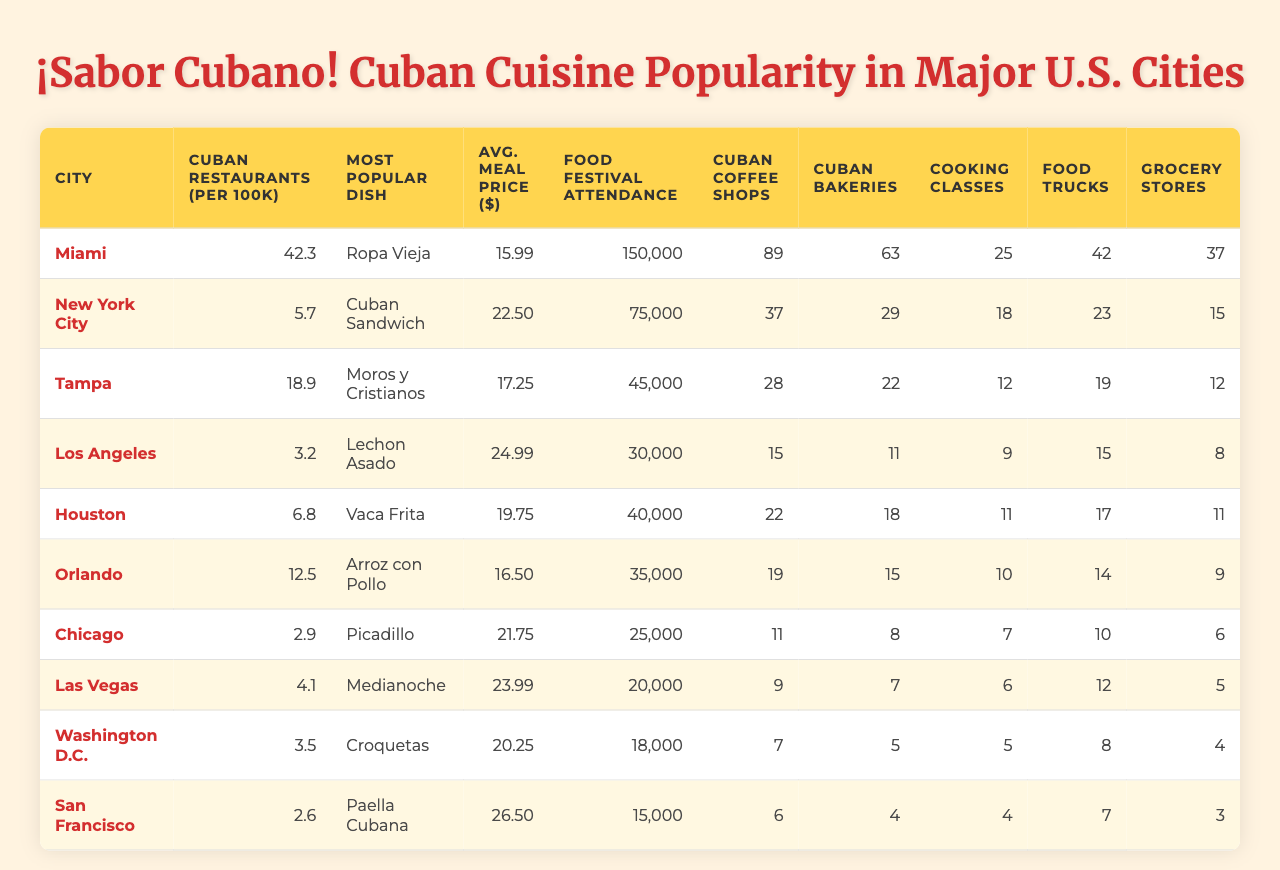What city has the highest number of Cuban restaurants per 100k people? Miami has the highest number of Cuban restaurants with 42.3 restaurants per 100k people, which is clearly indicated in the table.
Answer: Miami Which city has the lowest average price for a Cuban meal? Orlando has the lowest average price for a Cuban meal at $16.50, as shown in the relevant column of the table.
Answer: Orlando How many Cuban coffee shops are in New York City? New York City has 37 Cuban coffee shops, which can be found in the table.
Answer: 37 What is the most popular Cuban dish in Chicago? The most popular Cuban dish in Chicago is Picadillo, clearly listed in the table under the corresponding column for that city.
Answer: Picadillo Which city has more Cuban grocery stores: Tampa or Orlando? Tampa has 12 Cuban grocery stores while Orlando has 9. Therefore, Tampa has more grocery stores than Orlando.
Answer: Tampa What is the total attendance for Cuban food festivals in Miami and Tampa combined? The attendance for Cuban food festivals in Miami is 150,000 and in Tampa is 45,000. Adding these together gives 150,000 + 45,000 = 195,000.
Answer: 195,000 True or False: Los Angeles has more Cuban bakeries than Cuban coffee shops. In Los Angeles, there are 11 Cuban bakeries and 15 Cuban coffee shops, therefore the statement is false.
Answer: False In which city is the most popular Cuban dish Lechon Asado, and what is its average meal price? Lechon Asado is the most popular dish in Los Angeles, where the average meal price is $24.99, as shown in the table.
Answer: Los Angeles, $24.99 Which city has the highest attendance at Cuban food festivals and by how much does it exceed the second city? Miami has the highest attendance at 150,000, while New York City has 75,000. The difference is 150,000 - 75,000 = 75,000.
Answer: 75,000 What is the combined number of Cuban food trucks in Chicago and Orlando? Chicago has 10 Cuban food trucks and Orlando has 14. The total is 10 + 14 = 24.
Answer: 24 